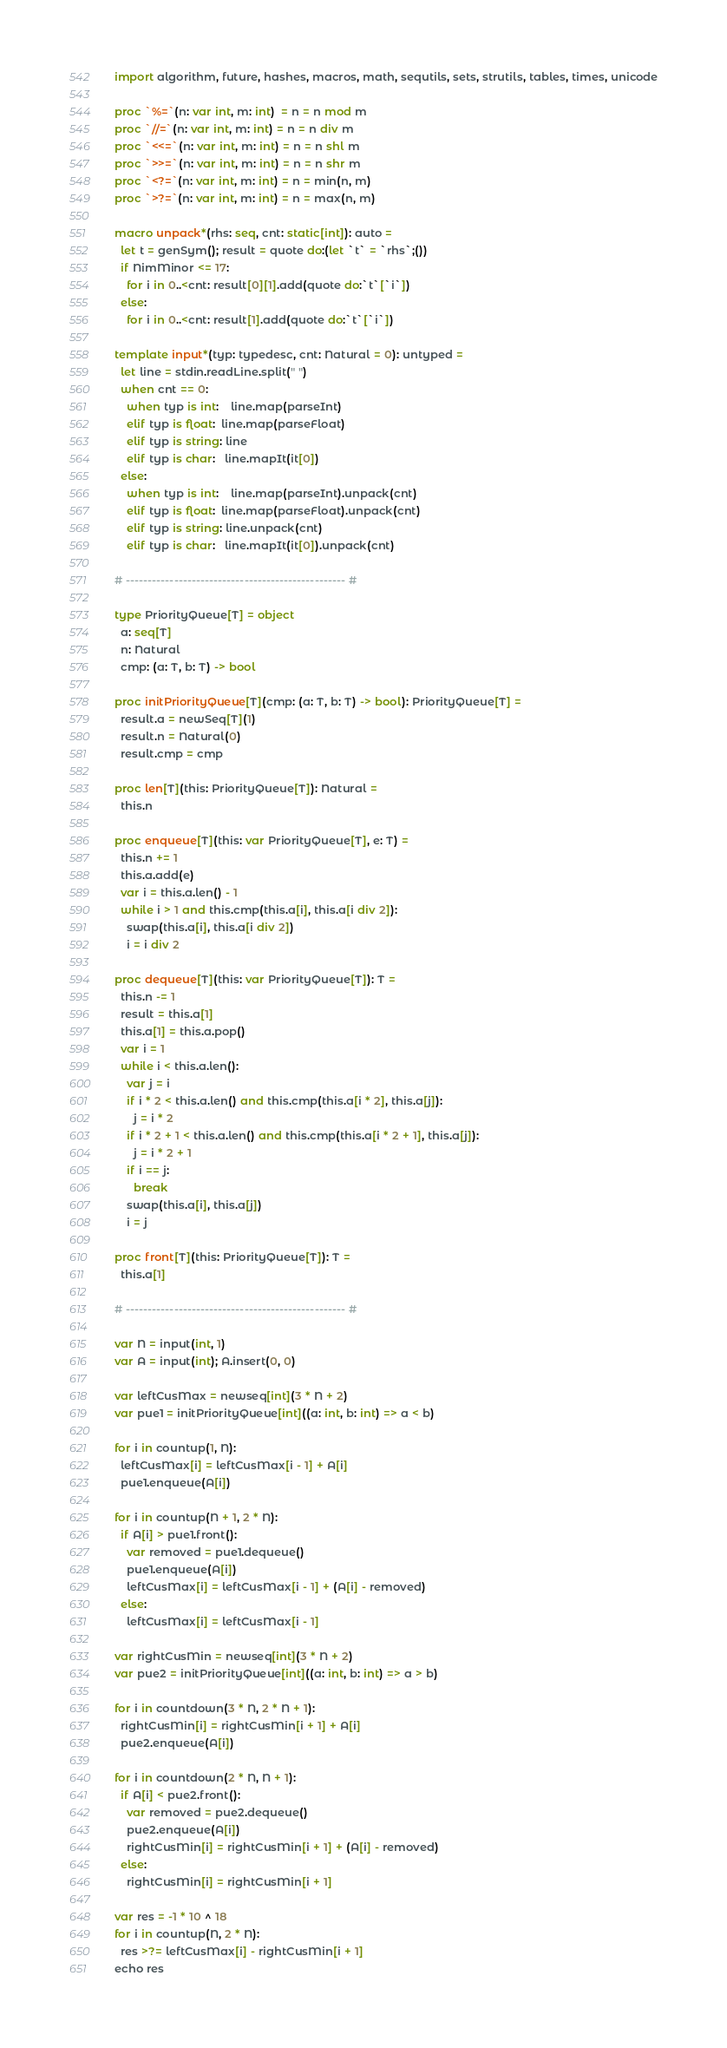Convert code to text. <code><loc_0><loc_0><loc_500><loc_500><_Nim_>import algorithm, future, hashes, macros, math, sequtils, sets, strutils, tables, times, unicode

proc `%=`(n: var int, m: int)  = n = n mod m
proc `//=`(n: var int, m: int) = n = n div m
proc `<<=`(n: var int, m: int) = n = n shl m
proc `>>=`(n: var int, m: int) = n = n shr m
proc `<?=`(n: var int, m: int) = n = min(n, m)
proc `>?=`(n: var int, m: int) = n = max(n, m)

macro unpack*(rhs: seq, cnt: static[int]): auto =
  let t = genSym(); result = quote do:(let `t` = `rhs`;())
  if NimMinor <= 17:
    for i in 0..<cnt: result[0][1].add(quote do:`t`[`i`])
  else:
    for i in 0..<cnt: result[1].add(quote do:`t`[`i`])

template input*(typ: typedesc, cnt: Natural = 0): untyped =
  let line = stdin.readLine.split(" ")
  when cnt == 0:
    when typ is int:    line.map(parseInt)
    elif typ is float:  line.map(parseFloat)
    elif typ is string: line
    elif typ is char:   line.mapIt(it[0])
  else:
    when typ is int:    line.map(parseInt).unpack(cnt)
    elif typ is float:  line.map(parseFloat).unpack(cnt)
    elif typ is string: line.unpack(cnt)
    elif typ is char:   line.mapIt(it[0]).unpack(cnt)

# -------------------------------------------------- #

type PriorityQueue[T] = object
  a: seq[T]
  n: Natural
  cmp: (a: T, b: T) -> bool
 
proc initPriorityQueue[T](cmp: (a: T, b: T) -> bool): PriorityQueue[T] =
  result.a = newSeq[T](1)
  result.n = Natural(0)
  result.cmp = cmp
 
proc len[T](this: PriorityQueue[T]): Natural =
  this.n
 
proc enqueue[T](this: var PriorityQueue[T], e: T) =
  this.n += 1
  this.a.add(e)
  var i = this.a.len() - 1
  while i > 1 and this.cmp(this.a[i], this.a[i div 2]):
    swap(this.a[i], this.a[i div 2])
    i = i div 2
 
proc dequeue[T](this: var PriorityQueue[T]): T =
  this.n -= 1
  result = this.a[1]
  this.a[1] = this.a.pop()
  var i = 1
  while i < this.a.len():
    var j = i
    if i * 2 < this.a.len() and this.cmp(this.a[i * 2], this.a[j]):
      j = i * 2
    if i * 2 + 1 < this.a.len() and this.cmp(this.a[i * 2 + 1], this.a[j]):
      j = i * 2 + 1
    if i == j:
      break
    swap(this.a[i], this.a[j])
    i = j
 
proc front[T](this: PriorityQueue[T]): T =
  this.a[1]

# -------------------------------------------------- #

var N = input(int, 1)
var A = input(int); A.insert(0, 0)

var leftCusMax = newseq[int](3 * N + 2)
var pue1 = initPriorityQueue[int]((a: int, b: int) => a < b)

for i in countup(1, N):
  leftCusMax[i] = leftCusMax[i - 1] + A[i]
  pue1.enqueue(A[i])

for i in countup(N + 1, 2 * N):
  if A[i] > pue1.front():
    var removed = pue1.dequeue()
    pue1.enqueue(A[i])
    leftCusMax[i] = leftCusMax[i - 1] + (A[i] - removed)
  else:
    leftCusMax[i] = leftCusMax[i - 1]

var rightCusMin = newseq[int](3 * N + 2)
var pue2 = initPriorityQueue[int]((a: int, b: int) => a > b)

for i in countdown(3 * N, 2 * N + 1):
  rightCusMin[i] = rightCusMin[i + 1] + A[i]
  pue2.enqueue(A[i])

for i in countdown(2 * N, N + 1):
  if A[i] < pue2.front():
    var removed = pue2.dequeue()
    pue2.enqueue(A[i])
    rightCusMin[i] = rightCusMin[i + 1] + (A[i] - removed)
  else:
    rightCusMin[i] = rightCusMin[i + 1]

var res = -1 * 10 ^ 18
for i in countup(N, 2 * N):
  res >?= leftCusMax[i] - rightCusMin[i + 1]
echo res</code> 